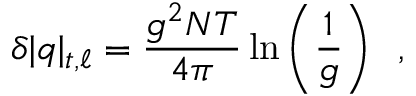<formula> <loc_0><loc_0><loc_500><loc_500>\delta | q | _ { t , \ell } = { \frac { g ^ { 2 } N T } { 4 \pi } } \ln \left ( { \frac { 1 } { g } } \right ) \, ,</formula> 